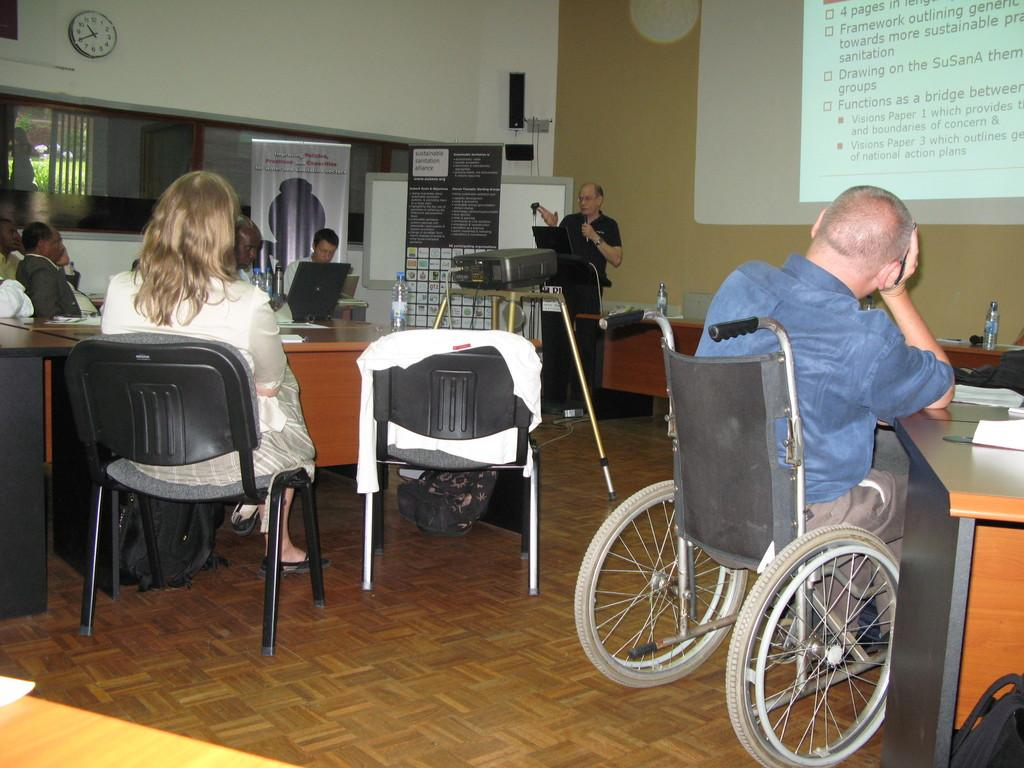What are the people in the image doing? The people in the image are sitting. Can you describe the man in the wheelchair? A man is sitting in a wheelchair. What can be seen in the background of the image? A: In the background, there is a man standing, a projector, a banner, a wall, and a clock. What type of berry is being used as an instrument in the image? There is no berry or instrument present in the image. How does the fight between the people in the image end? There is no fight present in the image; the people are sitting. 